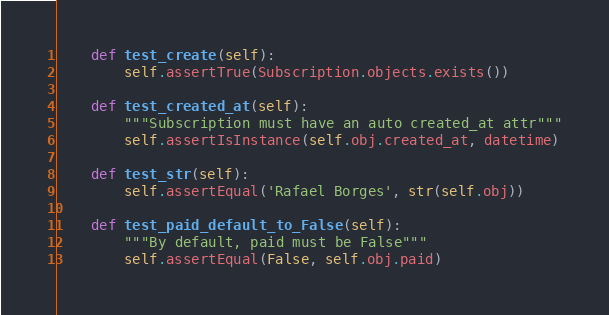<code> <loc_0><loc_0><loc_500><loc_500><_Python_>    def test_create(self):
        self.assertTrue(Subscription.objects.exists())

    def test_created_at(self):
        """Subscription must have an auto created_at attr"""
        self.assertIsInstance(self.obj.created_at, datetime)

    def test_str(self):
        self.assertEqual('Rafael Borges', str(self.obj))

    def test_paid_default_to_False(self):
        """By default, paid must be False"""
        self.assertEqual(False, self.obj.paid)
</code> 